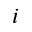Convert formula to latex. <formula><loc_0><loc_0><loc_500><loc_500>i</formula> 